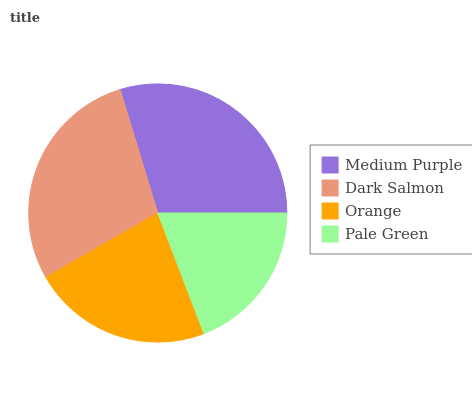Is Pale Green the minimum?
Answer yes or no. Yes. Is Medium Purple the maximum?
Answer yes or no. Yes. Is Dark Salmon the minimum?
Answer yes or no. No. Is Dark Salmon the maximum?
Answer yes or no. No. Is Medium Purple greater than Dark Salmon?
Answer yes or no. Yes. Is Dark Salmon less than Medium Purple?
Answer yes or no. Yes. Is Dark Salmon greater than Medium Purple?
Answer yes or no. No. Is Medium Purple less than Dark Salmon?
Answer yes or no. No. Is Dark Salmon the high median?
Answer yes or no. Yes. Is Orange the low median?
Answer yes or no. Yes. Is Pale Green the high median?
Answer yes or no. No. Is Medium Purple the low median?
Answer yes or no. No. 